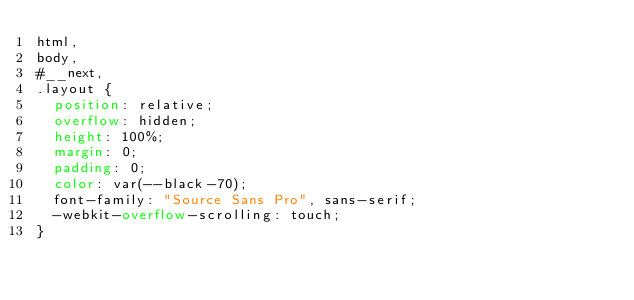<code> <loc_0><loc_0><loc_500><loc_500><_CSS_>html,
body,
#__next,
.layout {
  position: relative;
  overflow: hidden;
  height: 100%;
  margin: 0;
  padding: 0;
  color: var(--black-70);
  font-family: "Source Sans Pro", sans-serif;
  -webkit-overflow-scrolling: touch;
}
</code> 